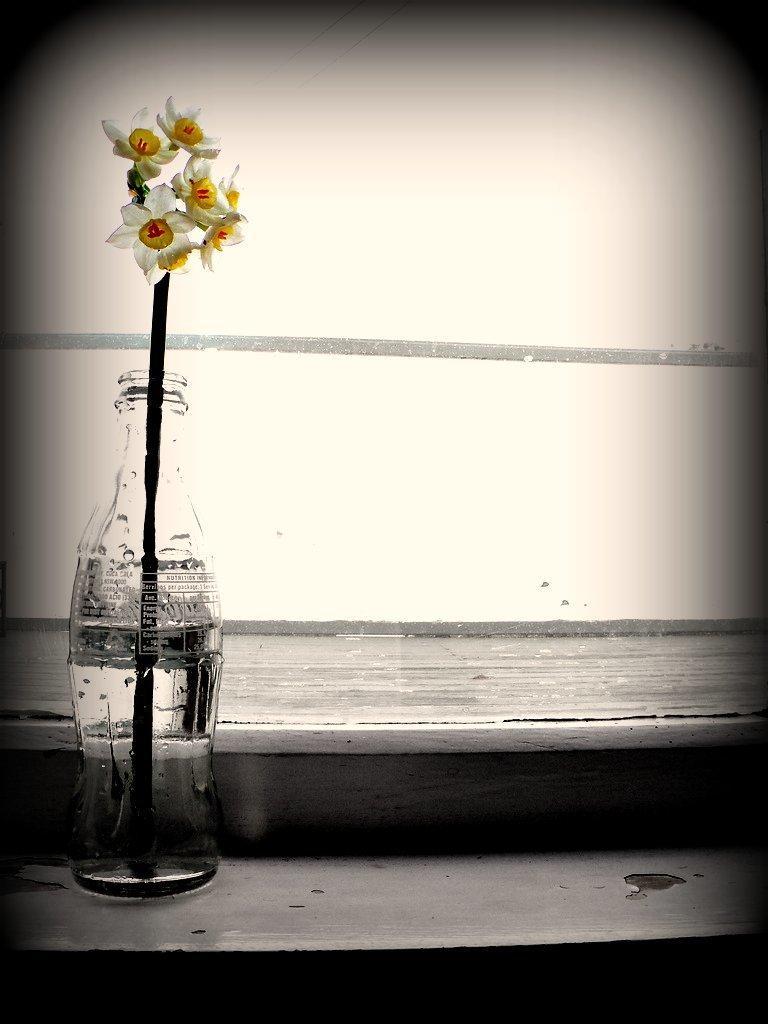Could you give a brief overview of what you see in this image? In this picture we can see a bottle placed on a wooden platform and inside this bottle we have a stick with flowers to it and in the background we can see wall. 